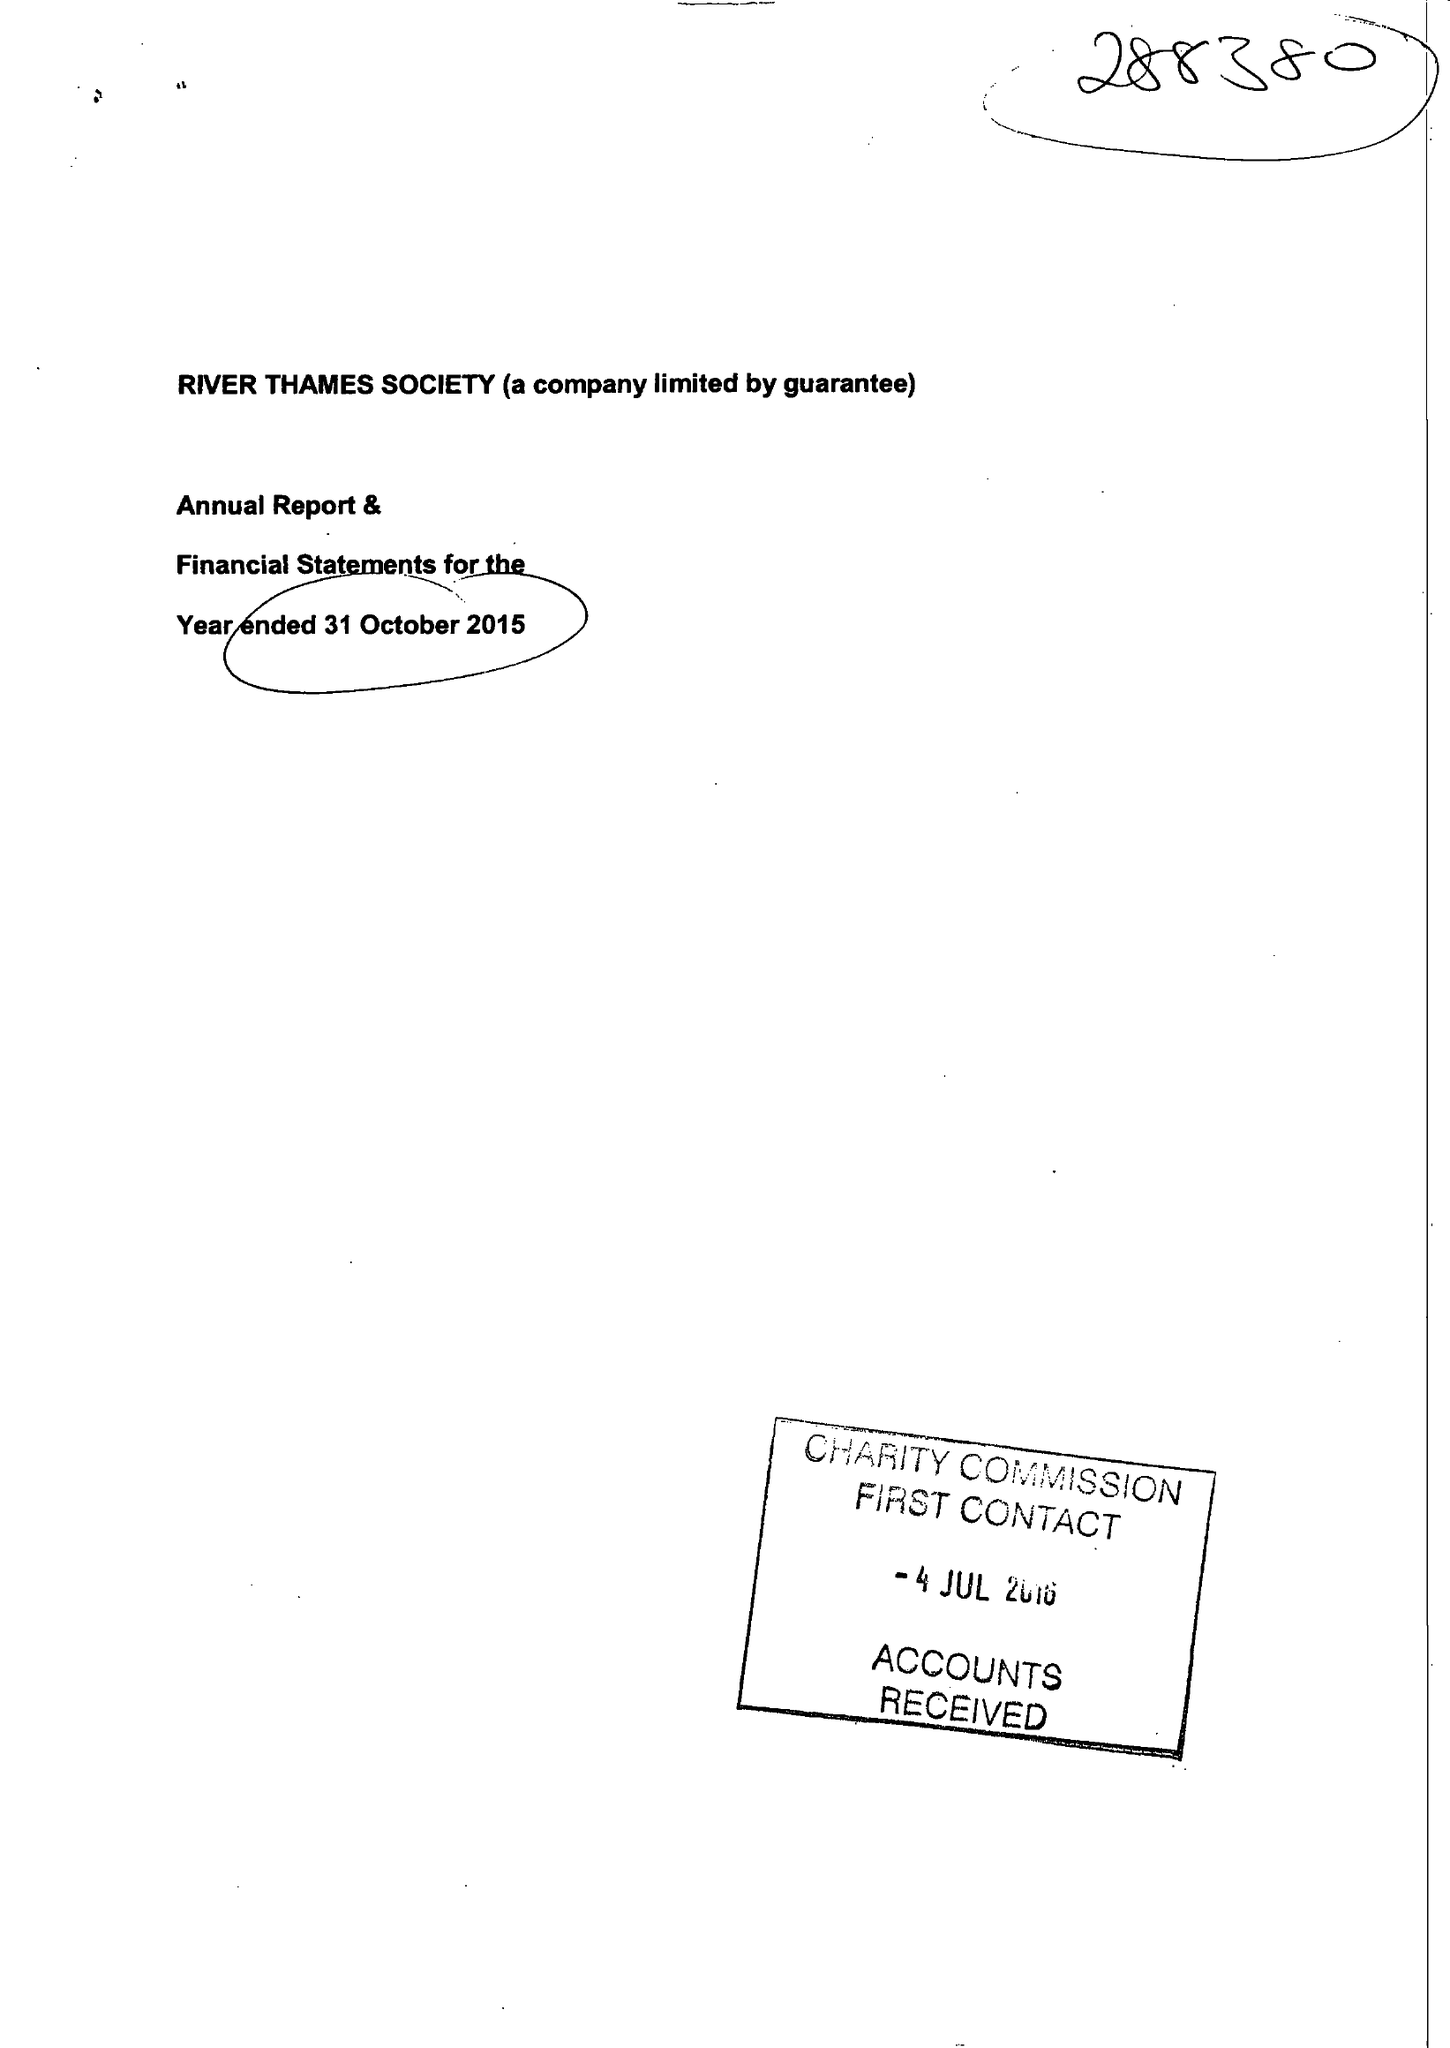What is the value for the address__postcode?
Answer the question using a single word or phrase. SL4 1JP 